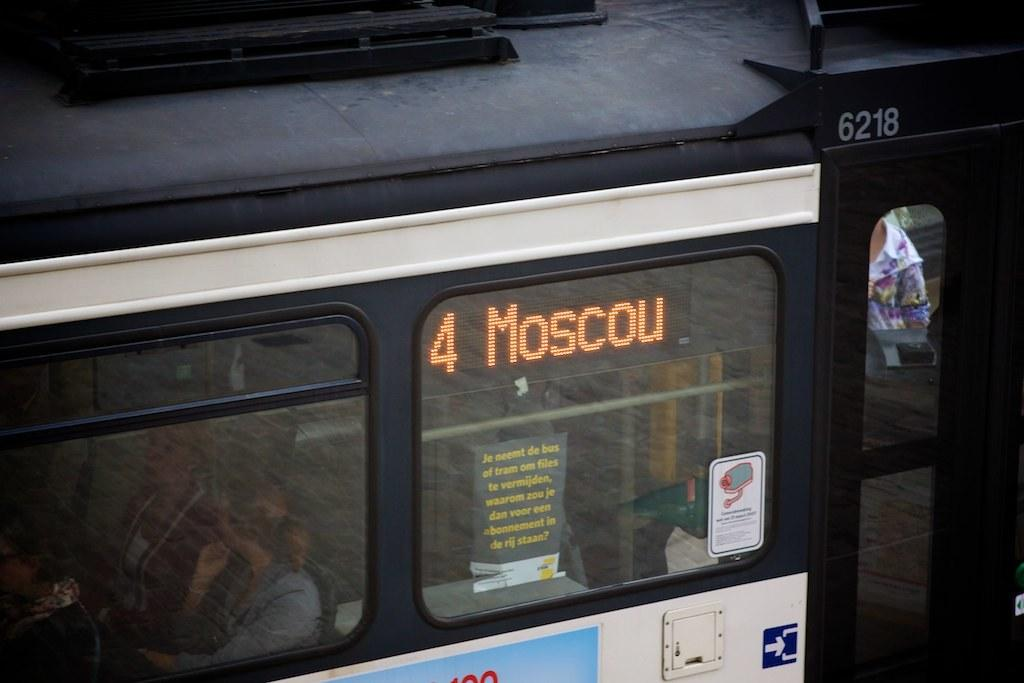<image>
Provide a brief description of the given image. A bus in Russia that is on route 4 going to Moscow. 